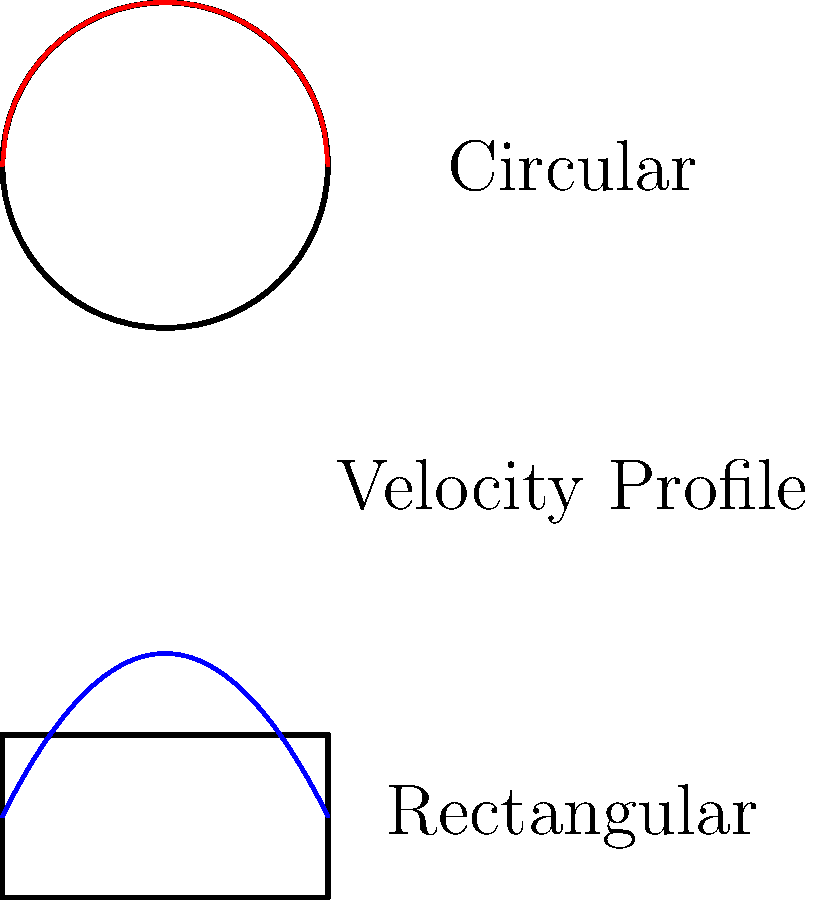In the context of AR development for fluid dynamics visualization, compare the velocity profiles of fully developed laminar flow in circular and rectangular pipes. How do these profiles differ, and what implications does this have for designing AR simulations of fluid flow in different pipe geometries? To answer this question, let's analyze the velocity profiles step-by-step:

1. Circular pipe:
   - The velocity profile in a circular pipe is parabolic.
   - It can be described by the equation: $v(r) = v_{max}(1 - \frac{r^2}{R^2})$
   - Where $v_{max}$ is the maximum velocity at the center, $r$ is the radial distance from the center, and $R$ is the pipe radius.
   - This results in a symmetric, smooth curve with zero velocity at the walls and maximum velocity at the center.

2. Rectangular pipe:
   - The velocity profile in a rectangular pipe is more complex.
   - It can be approximated by a series solution, but a simplified form is: $v(y,z) = v_{max}(1 - (\frac{y}{a})^2)(1 - (\frac{z}{b})^2)$
   - Where $a$ and $b$ are the half-width and half-height of the rectangular cross-section.
   - This profile is flatter in the center and drops off more sharply near the walls compared to the circular pipe.

3. Key differences:
   - The circular pipe has a more uniform velocity distribution across the cross-section.
   - The rectangular pipe has higher velocities near the corners and a more pronounced variation across the cross-section.

4. Implications for AR simulations:
   - Circular pipes: Simpler to model and visualize due to radial symmetry.
   - Rectangular pipes: Require more complex calculations and visualizations to accurately represent the flow patterns.
   - AR developers need to consider these differences when creating realistic fluid flow simulations.
   - The choice of pipe geometry will affect particle tracing, streamline visualization, and overall flow behavior in the AR environment.

5. Design considerations:
   - For circular pipes, focus on smooth transitions and radial symmetry in the visualization.
   - For rectangular pipes, emphasize the variations near the walls and corners.
   - Consider using color gradients or particle systems to highlight the velocity differences across the cross-sections.

By understanding these differences, AR developers can create more accurate and informative visualizations of fluid flow in different pipe geometries, enhancing the educational and analytical value of the AR application.
Answer: Circular pipes have parabolic velocity profiles with maximum velocity at the center, while rectangular pipes have flatter profiles with sharper drops near walls and corners, requiring more complex AR visualizations. 